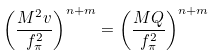Convert formula to latex. <formula><loc_0><loc_0><loc_500><loc_500>\left ( \frac { M ^ { 2 } v } { f _ { \pi } ^ { 2 } } \right ) ^ { n + m } = \left ( \frac { M Q } { f _ { \pi } ^ { 2 } } \right ) ^ { n + m }</formula> 